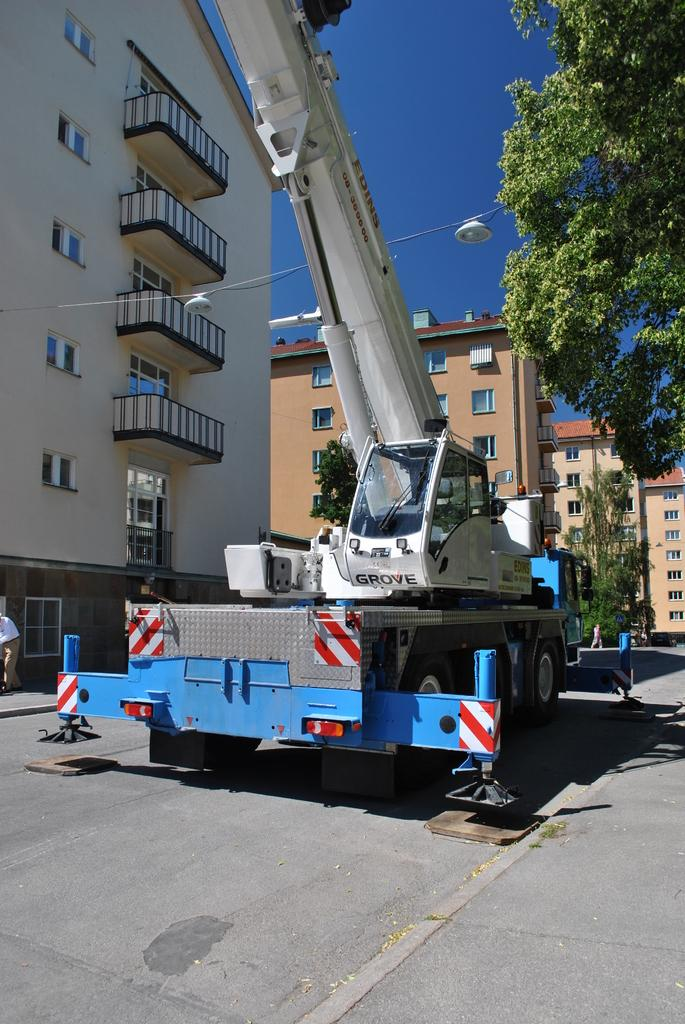What type of structures can be seen in the image? There are buildings in the image. What feature do the buildings have? The buildings have glass windows. What else can be seen in the image besides the buildings? There is a vehicle, trees, a light-pole, and people on the road in the image. What is the color of the sky in the image? The sky is blue in color. Where is the son sitting at the table in the image? There is no son or table present in the image. What type of ground is visible in the image? The ground is not explicitly visible in the image, but it can be inferred that there is a road or pavement based on the presence of people and vehicles. 